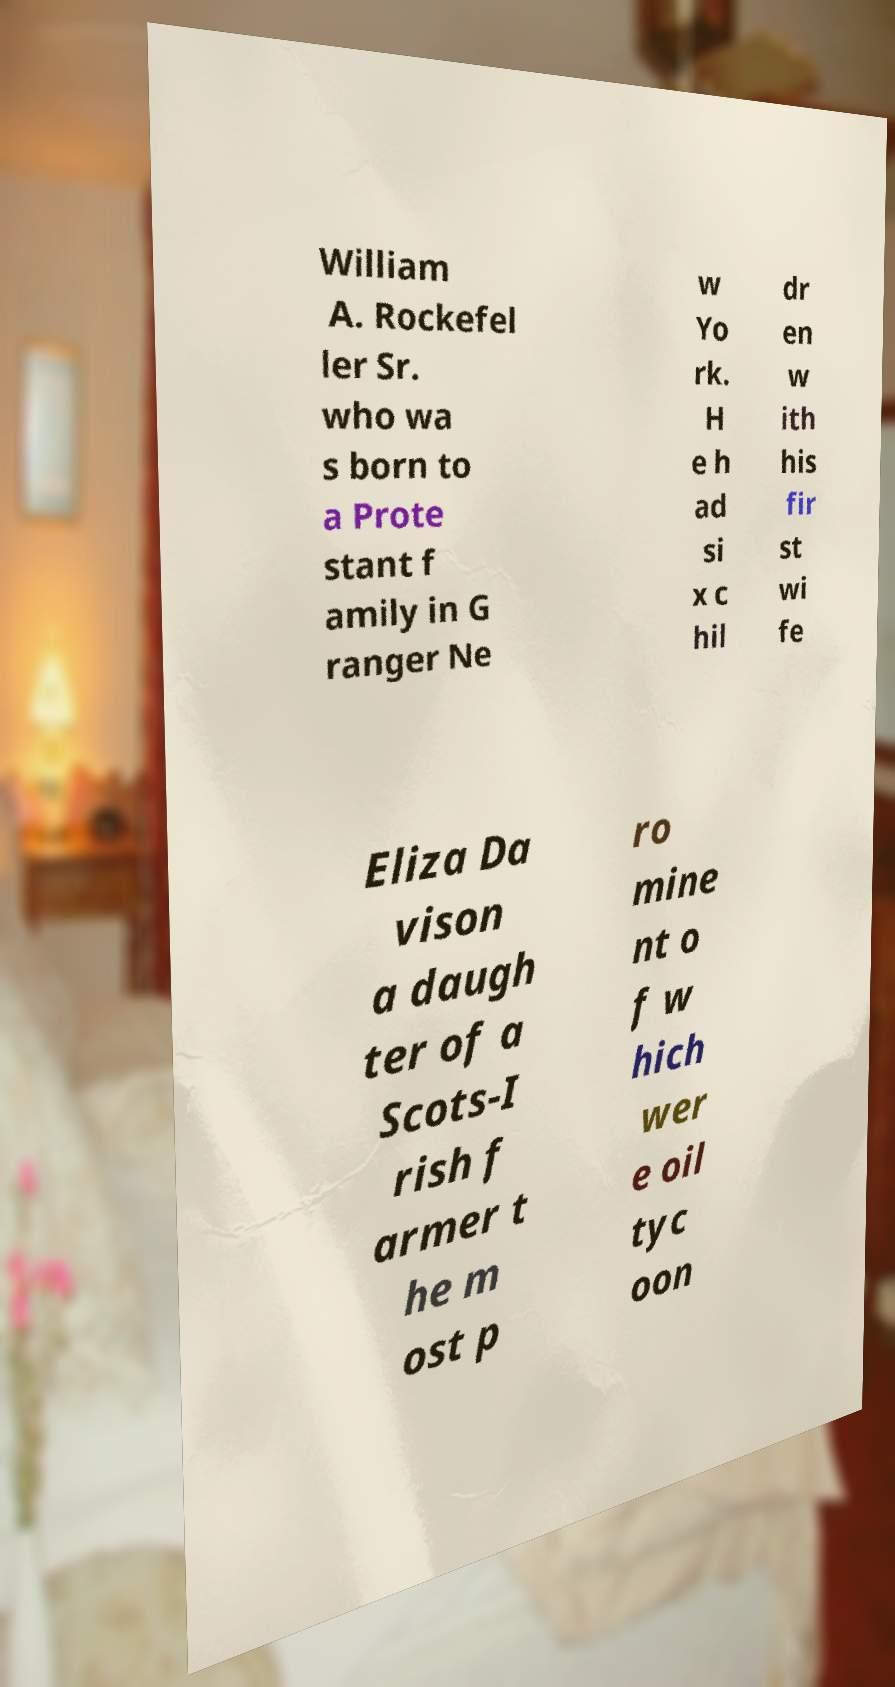What messages or text are displayed in this image? I need them in a readable, typed format. William A. Rockefel ler Sr. who wa s born to a Prote stant f amily in G ranger Ne w Yo rk. H e h ad si x c hil dr en w ith his fir st wi fe Eliza Da vison a daugh ter of a Scots-I rish f armer t he m ost p ro mine nt o f w hich wer e oil tyc oon 